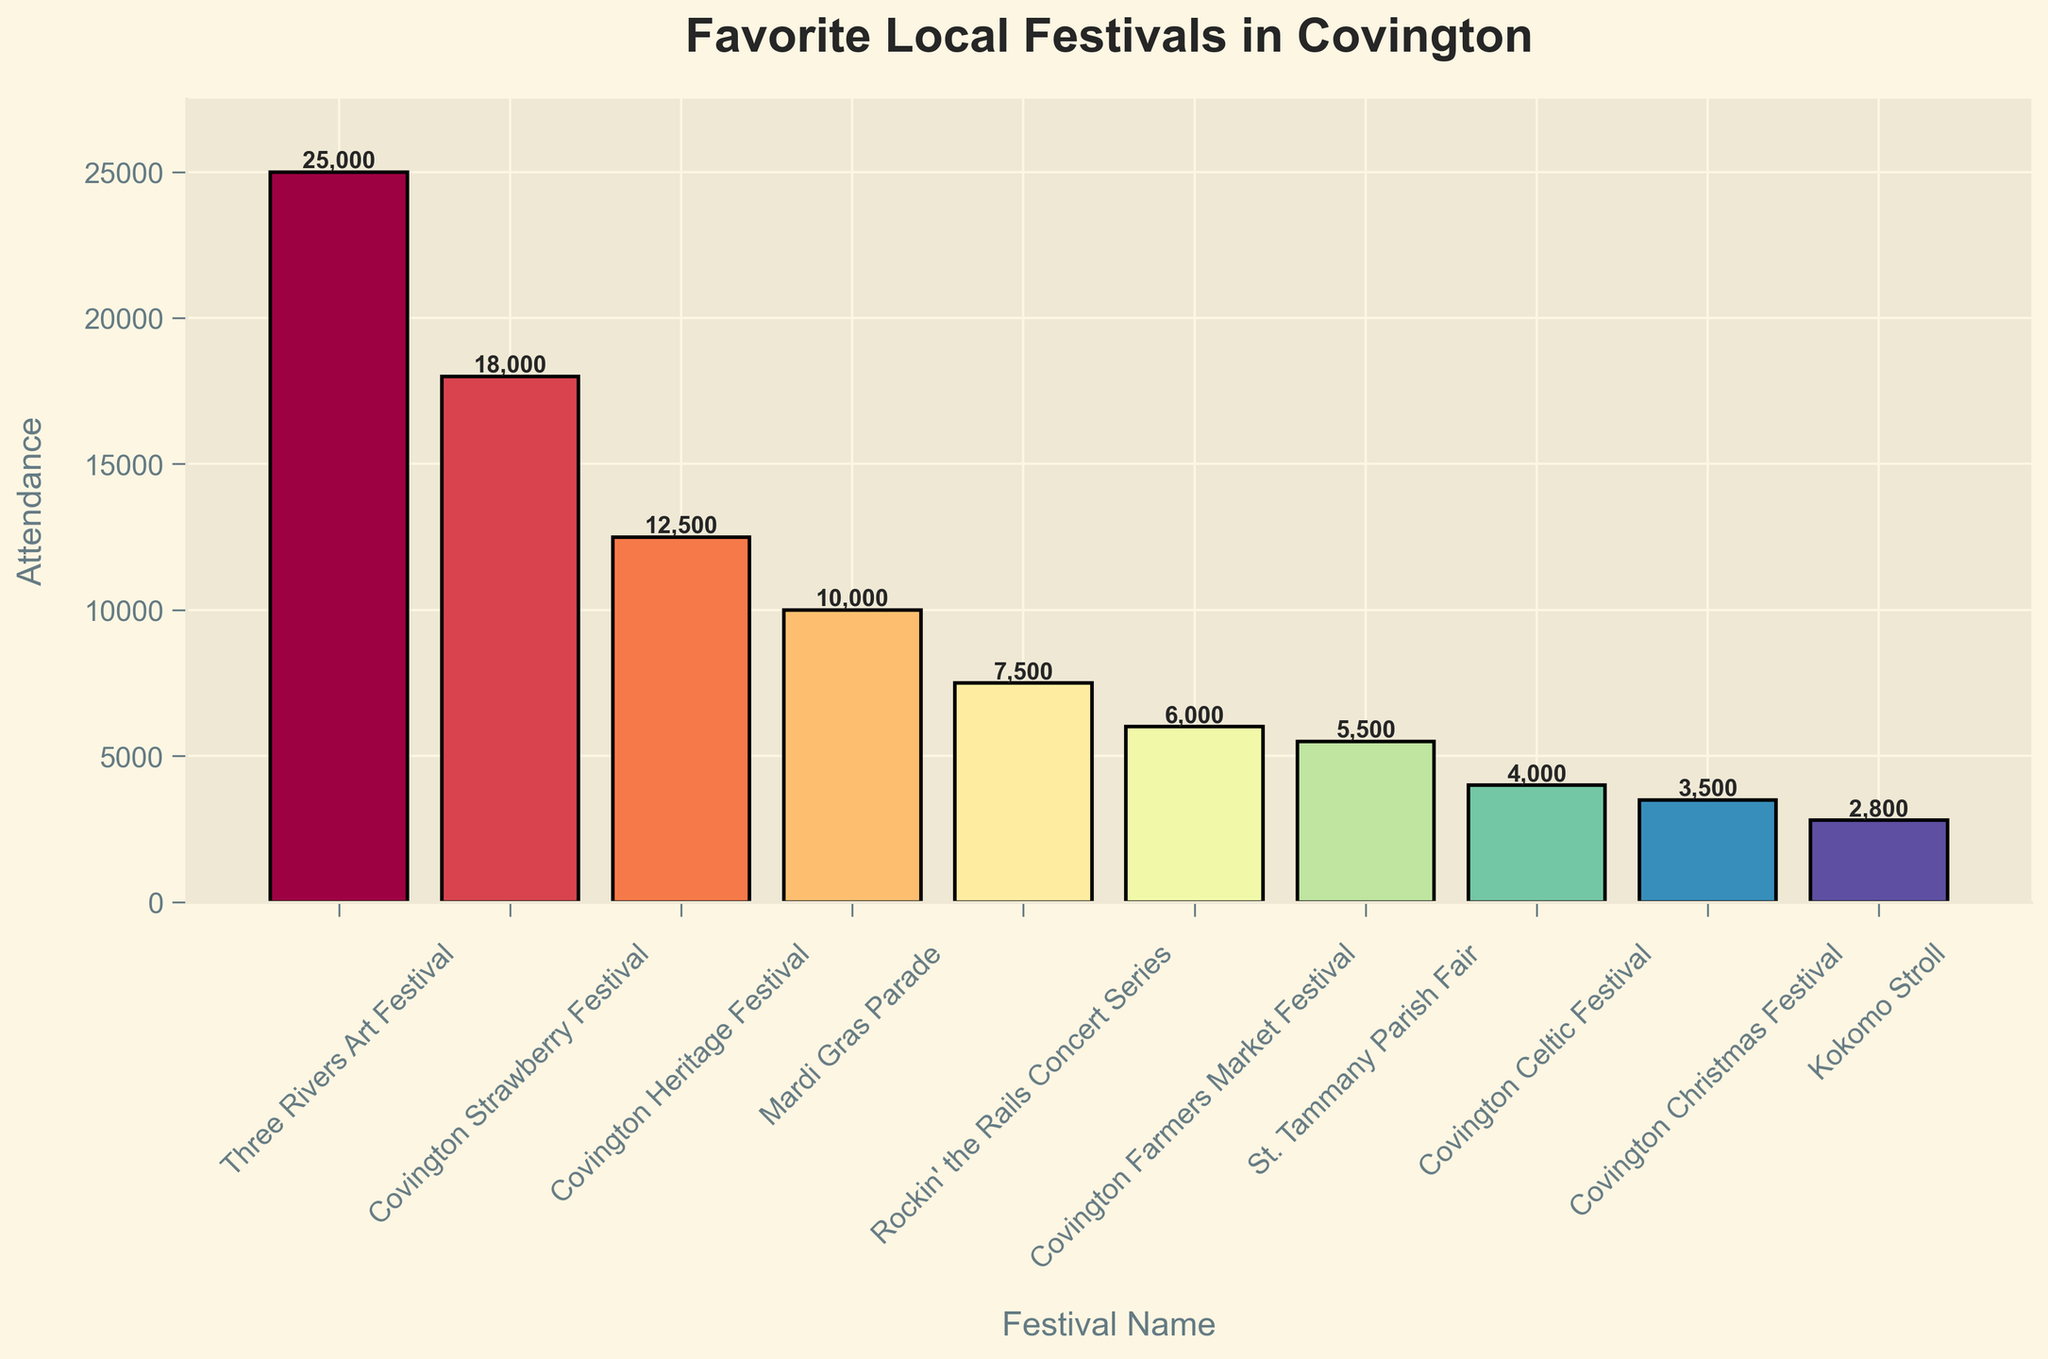Which festival has the highest attendance? The festival with the highest attendance will be the tallest bar in the plot. The tallest bar is labeled "Three Rivers Art Festival" with an attendance of 25,000.
Answer: Three Rivers Art Festival Which festival has the lowest attendance? The festival with the lowest attendance will be the shortest bar in the plot. The shortest bar is labeled "Kokomo Stroll" with an attendance of 2,800.
Answer: Kokomo Stroll What's the difference in attendance between the Covington Strawberry Festival and the Covington Celtic Festival? The attendance of the Covington Strawberry Festival is 18,000 and that of the Covington Celtic Festival is 4,000. The difference is calculated as 18,000 - 4,000 = 14,000.
Answer: 14,000 Which festival has closer attendance to the Covington Farmers Market Festival, the St. Tammany Parish Fair or the Covington Celtic Festival? Compare the attendance of the Covington Farmers Market Festival (6,000) with both the St. Tammany Parish Fair (5,500) and the Covington Celtic Festival (4,000). The difference is 500 for the St. Tammany Parish Fair and 2,000 for the Covington Celtic Festival. Thus, the St. Tammany Parish Fair has closer attendance.
Answer: St. Tammany Parish Fair How many festivals have attendance greater than 10,000? Find all the bars with a height greater than 10,000. These are "Three Rivers Art Festival" (25,000), "Covington Strawberry Festival" (18,000), and "Covington Heritage Festival" (12,500). So, there are 3 festivals with attendance greater than 10,000.
Answer: 3 What's the combined attendance of Mardi Gras Parade and Rockin' the Rails Concert Series? The attendance for Mardi Gras Parade is 10,000 and for Rockin' the Rails Concert Series is 7,500. Summing them: 10,000 + 7,500 = 17,500.
Answer: 17,500 What's the average attendance of the top 3 festivals? The top 3 festivals by attendance are "Three Rivers Art Festival" (25,000), "Covington Strawberry Festival" (18,000), and "Covington Heritage Festival" (12,500). The average is calculated as (25,000 + 18,000 + 12,500) / 3 = 18,500.
Answer: 18,500 Which festival has a bar color that transitions more towards green? Observing the color gradient on the bar chart, the "Rockin' the Rails Concert Series" bar appears greener compared to the other bars.
Answer: Rockin' the Rails Concert Series What's the median attendance of all the festivals listed? First, list attendance numbers in ascending order: 2,800, 3,500, 4,000, 5,500, 6,000, 7,500, 10,000, 12,500, 18,000, 25,000. Since there are 10 data points, the median is the average of the 5th and 6th values: (6,000 + 7,500) / 2 = 6,750.
Answer: 6,750 